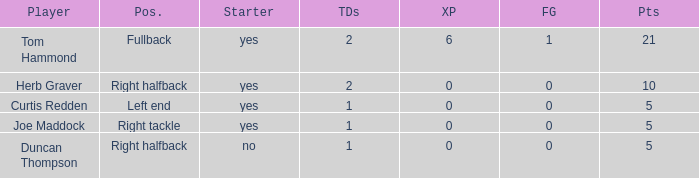Name the number of points for field goals being 1 1.0. 